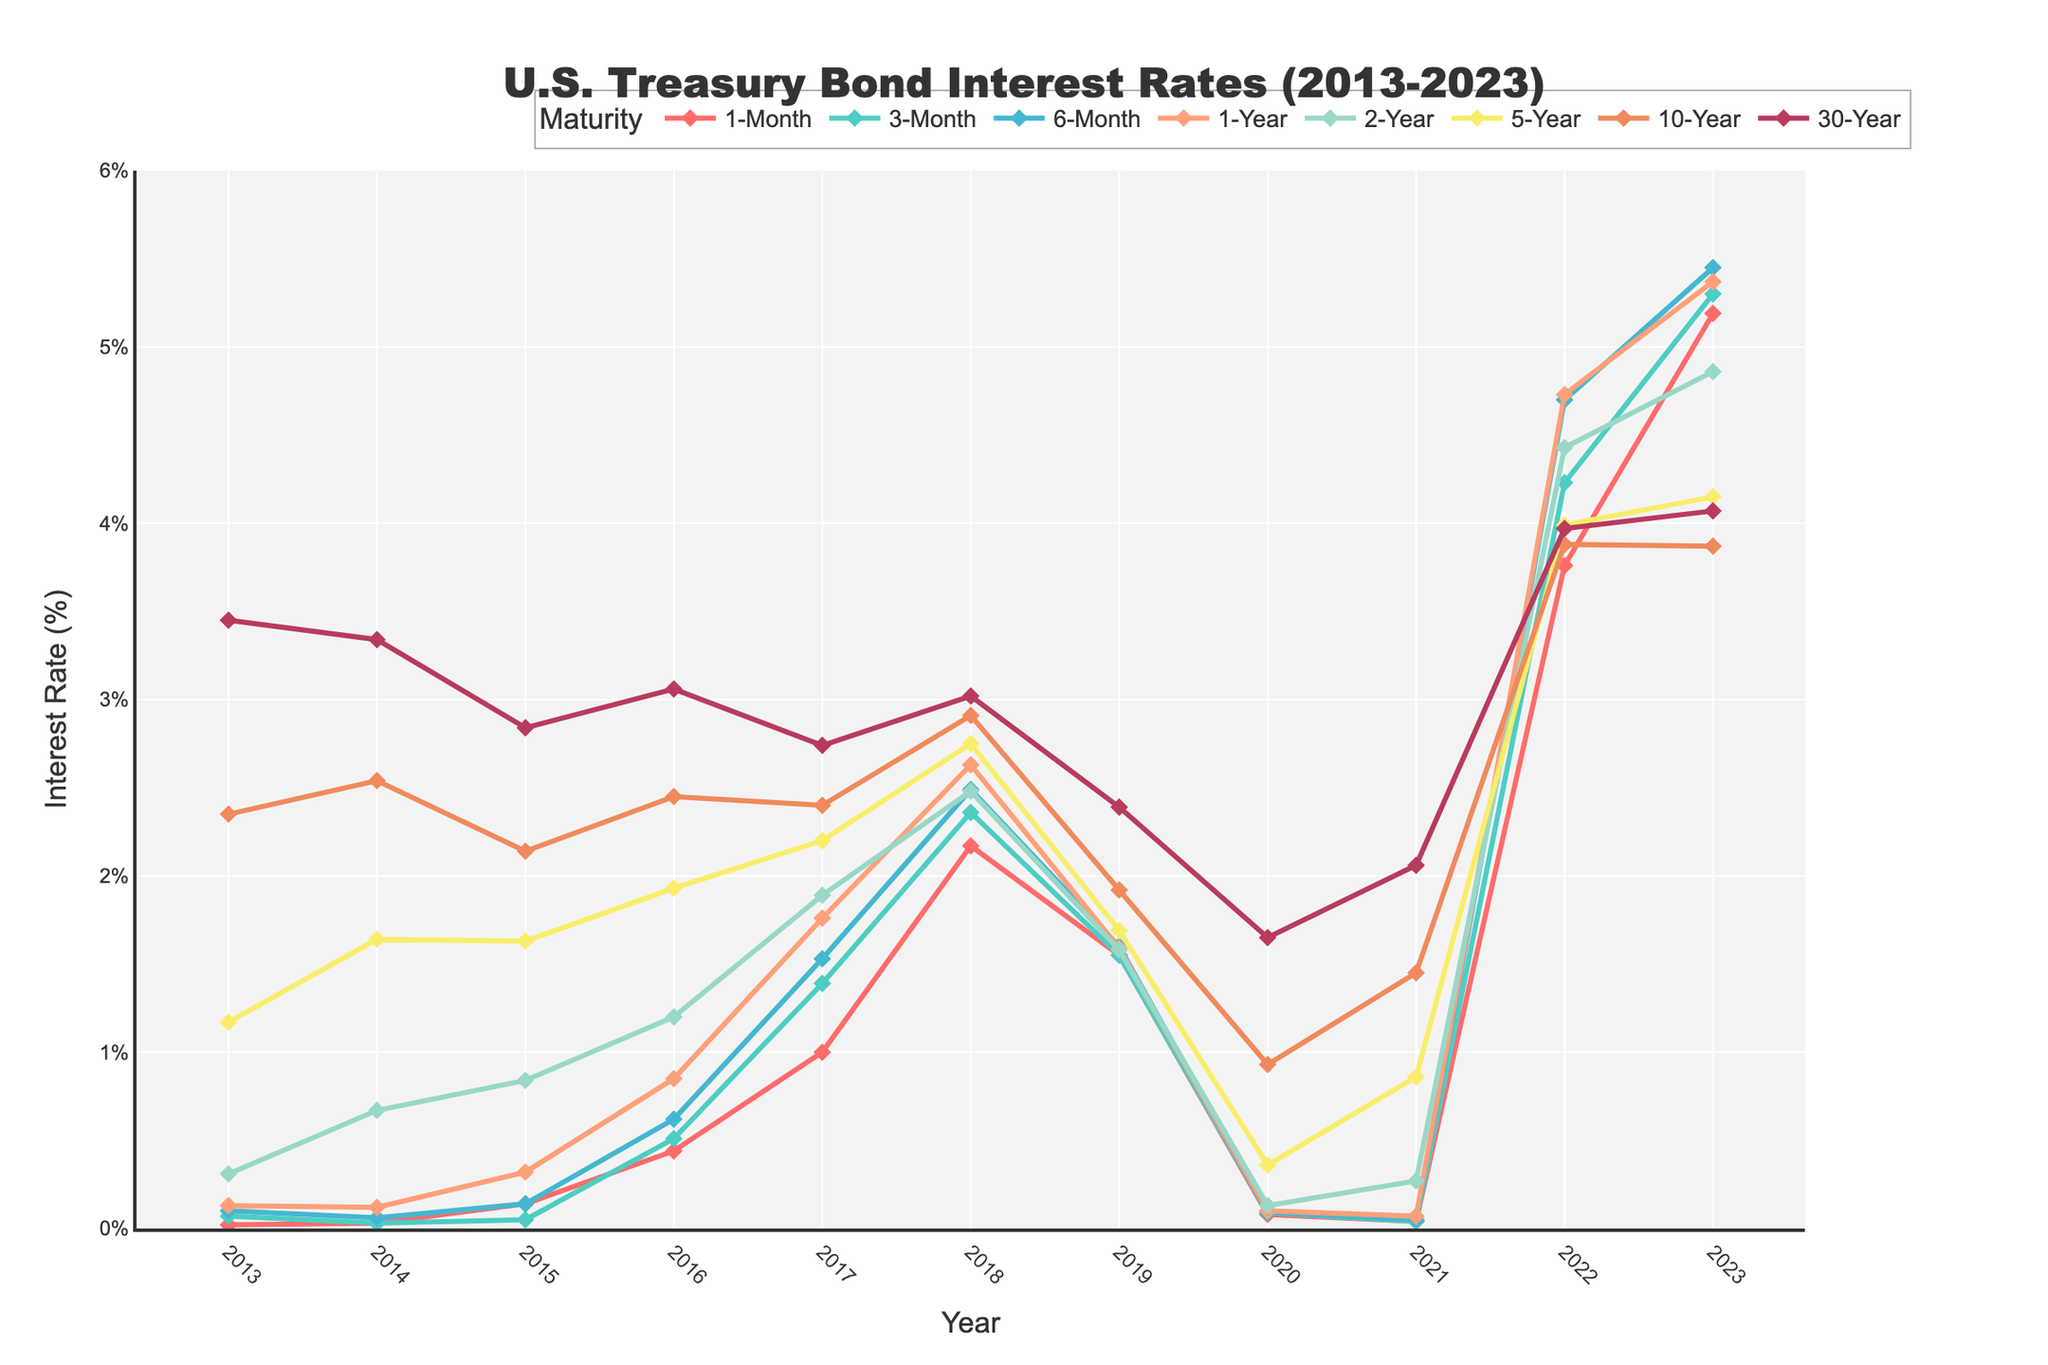What is the general trend for the 1-Month Treasury bond interest rate from 2013 to 2023? By observing the line representing the 1-Month Treasury bond interest rate, it starts close to zero in 2013, increases gradually, peaks around 2023, and fluctuates through the period.
Answer: Upward trend In which year did the 30-Year Treasury bond interest rate reach its highest value? By examining the highest point on the line corresponding to the 30-Year Treasury bond, it is clear that the highest value is in the year 2013.
Answer: 2013 Which maturity period showed the sharpest increase in interest rates from 2021 to 2022? By comparing the slopes of the lines between these years, the 1-Month, 3-Month, and 6-Month lines show the steepest increases. The 6-Month rate has the most significant jump.
Answer: 6-Month Which year had the lowest interest rates across all maturities? By noting the years with the lowest rates across multiple maturities, 2020 stands out as the year with significantly lower interest rates across the board.
Answer: 2020 What is the average interest rate for the 10-Year Treasury bond over the decade? Adding up the interest rates for the 10-Year Treasury bond from 2013 to 2023 and dividing by the number of years (11), the average is (2.35 + 2.54 + 2.14 + 2.45 + 2.40 + 2.91 + 1.92 + 0.93 + 1.45 + 3.88 + 3.87) / 11 = 2.44.
Answer: 2.44 How do the interest rates for short-term (1-Month) and long-term (30-Year) Treasury bonds in 2023 compare? Compare the end points of the lines for 1-Month and 30-Year Treasury bonds in 2023; the 1-Month rate is higher than the 30-Year rate in 2023.
Answer: 1-Month > 30-Year Which year did the 5-Year Treasury bond and the 10-Year Treasury bond interest rate differ the most? By calculating the absolute difference between the 5-Year and 10-Year rates for each year and finding the maximum difference, the most distinct gap occurs in 2023.
Answer: 2023 What is the median interest rate for the 2-Year Treasury bond over the past decade? Ordering the interest rates for the 2-Year Treasury bond and finding the middle value, the median is the value at the 6th position in the ordered list (0.13, 0.27, 0.31, 0.67, 0.84, 1.20, 1.58, 1.89, 2.48, 4.43, 4.86), i.e., 1.20.
Answer: 1.20 